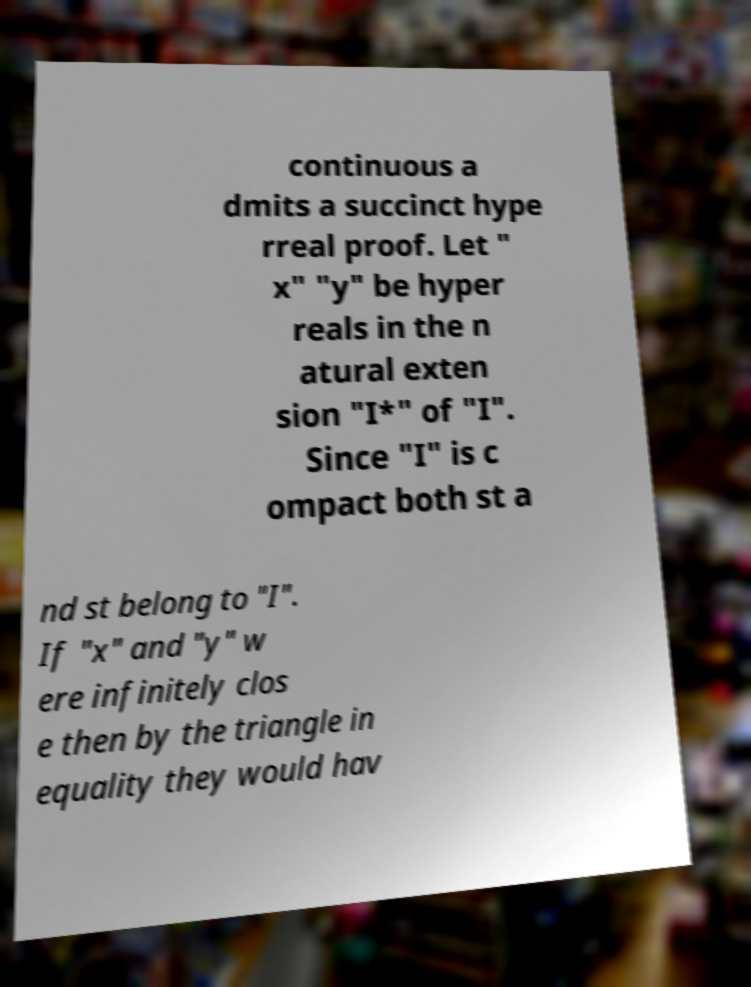I need the written content from this picture converted into text. Can you do that? continuous a dmits a succinct hype rreal proof. Let " x" "y" be hyper reals in the n atural exten sion "I*" of "I". Since "I" is c ompact both st a nd st belong to "I". If "x" and "y" w ere infinitely clos e then by the triangle in equality they would hav 